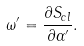<formula> <loc_0><loc_0><loc_500><loc_500>\omega ^ { \prime } = \frac { \partial S _ { c l } } { \partial \alpha ^ { \prime } } .</formula> 